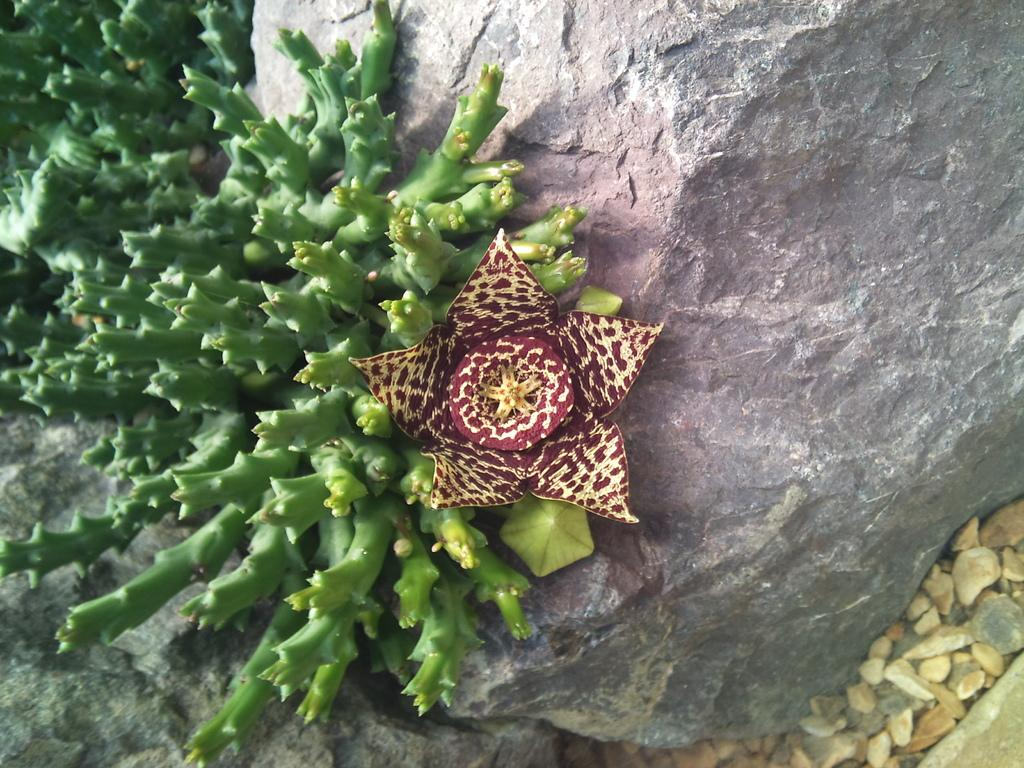What type of living organisms can be seen in the image? Plants and a flower are visible in the image. What other objects can be seen in the image? There is a rock and stones in the image. What type of meat is being grilled in the image? There is no meat or grill present in the image. What hobbies are the plants participating in during the image? Plants do not have hobbies, as they are living organisms and not sentient beings. 